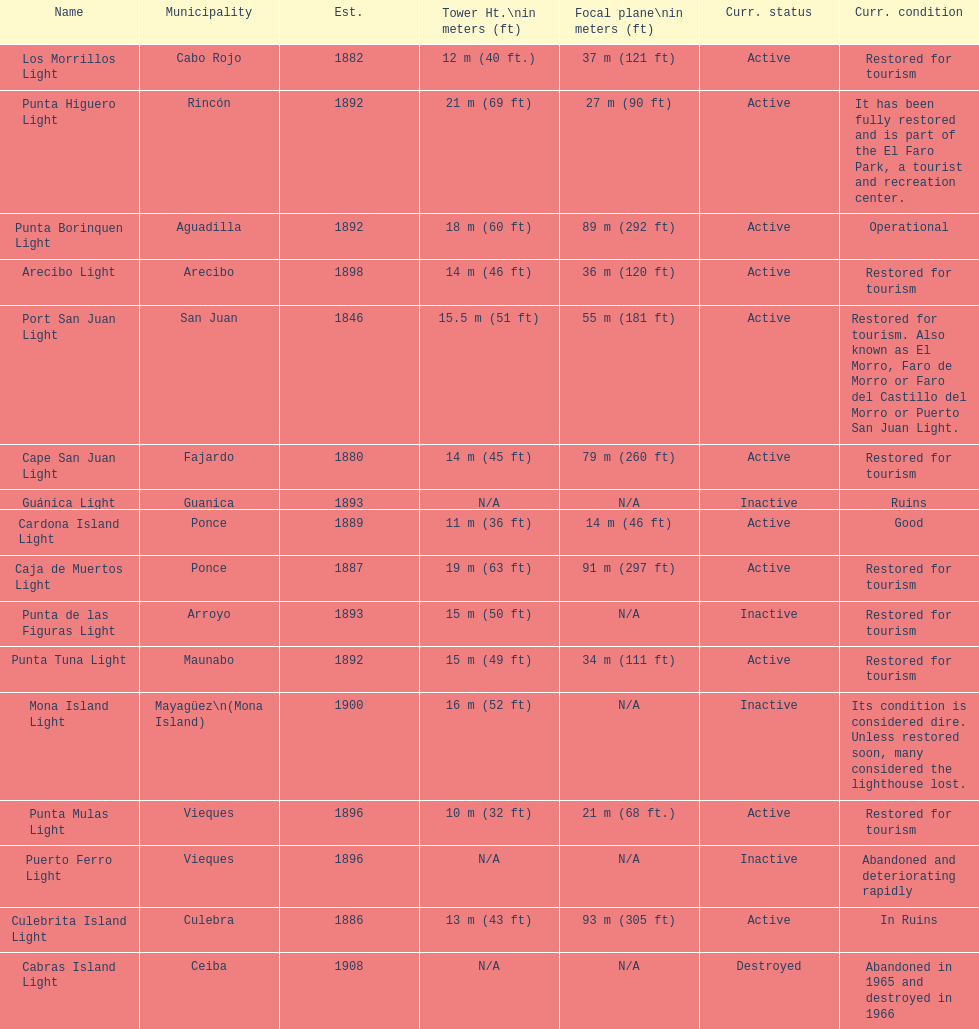How many towers are not shorter than 18 meters? 3. 